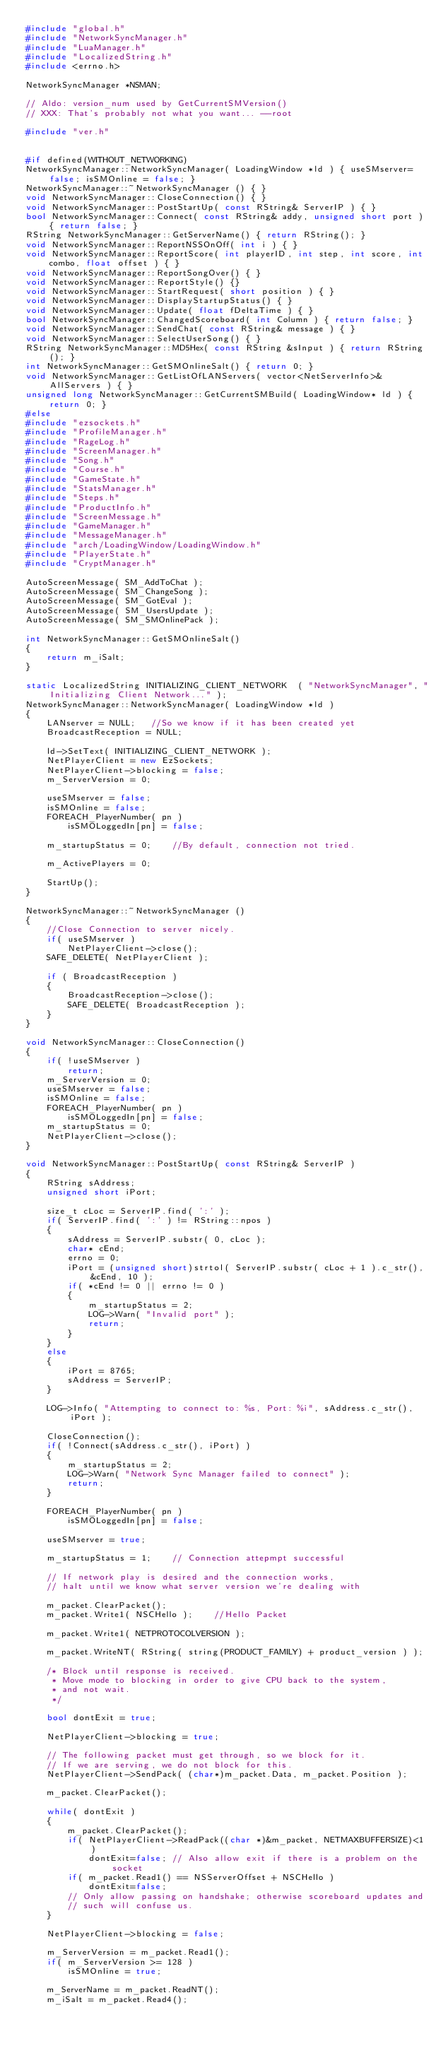Convert code to text. <code><loc_0><loc_0><loc_500><loc_500><_C++_>#include "global.h"
#include "NetworkSyncManager.h"
#include "LuaManager.h"
#include "LocalizedString.h"
#include <errno.h>

NetworkSyncManager *NSMAN;

// Aldo: version_num used by GetCurrentSMVersion()
// XXX: That's probably not what you want... --root

#include "ver.h"


#if defined(WITHOUT_NETWORKING)
NetworkSyncManager::NetworkSyncManager( LoadingWindow *ld ) { useSMserver=false; isSMOnline = false; }
NetworkSyncManager::~NetworkSyncManager () { }
void NetworkSyncManager::CloseConnection() { }
void NetworkSyncManager::PostStartUp( const RString& ServerIP ) { }
bool NetworkSyncManager::Connect( const RString& addy, unsigned short port ) { return false; }
RString NetworkSyncManager::GetServerName() { return RString(); }
void NetworkSyncManager::ReportNSSOnOff( int i ) { }
void NetworkSyncManager::ReportScore( int playerID, int step, int score, int combo, float offset ) { }
void NetworkSyncManager::ReportSongOver() { }
void NetworkSyncManager::ReportStyle() {}
void NetworkSyncManager::StartRequest( short position ) { }
void NetworkSyncManager::DisplayStartupStatus() { }
void NetworkSyncManager::Update( float fDeltaTime ) { }
bool NetworkSyncManager::ChangedScoreboard( int Column ) { return false; }
void NetworkSyncManager::SendChat( const RString& message ) { }
void NetworkSyncManager::SelectUserSong() { }
RString NetworkSyncManager::MD5Hex( const RString &sInput ) { return RString(); }
int NetworkSyncManager::GetSMOnlineSalt() { return 0; }
void NetworkSyncManager::GetListOfLANServers( vector<NetServerInfo>& AllServers ) { }
unsigned long NetworkSyncManager::GetCurrentSMBuild( LoadingWindow* ld ) { return 0; }
#else
#include "ezsockets.h"
#include "ProfileManager.h"
#include "RageLog.h"
#include "ScreenManager.h"
#include "Song.h"
#include "Course.h"
#include "GameState.h"
#include "StatsManager.h"
#include "Steps.h"
#include "ProductInfo.h"
#include "ScreenMessage.h"
#include "GameManager.h"
#include "MessageManager.h"
#include "arch/LoadingWindow/LoadingWindow.h"
#include "PlayerState.h"
#include "CryptManager.h"

AutoScreenMessage( SM_AddToChat );
AutoScreenMessage( SM_ChangeSong );
AutoScreenMessage( SM_GotEval );
AutoScreenMessage( SM_UsersUpdate );
AutoScreenMessage( SM_SMOnlinePack );

int NetworkSyncManager::GetSMOnlineSalt()
{
	return m_iSalt;
}

static LocalizedString INITIALIZING_CLIENT_NETWORK	( "NetworkSyncManager", "Initializing Client Network..." );
NetworkSyncManager::NetworkSyncManager( LoadingWindow *ld )
{
	LANserver = NULL;	//So we know if it has been created yet
	BroadcastReception = NULL;

	ld->SetText( INITIALIZING_CLIENT_NETWORK );
	NetPlayerClient = new EzSockets;
	NetPlayerClient->blocking = false;
	m_ServerVersion = 0;
   
	useSMserver = false;
	isSMOnline = false;
	FOREACH_PlayerNumber( pn )
		isSMOLoggedIn[pn] = false;

	m_startupStatus = 0;	//By default, connection not tried.

	m_ActivePlayers = 0;

	StartUp();
}

NetworkSyncManager::~NetworkSyncManager ()
{
	//Close Connection to server nicely.
	if( useSMserver )
		NetPlayerClient->close();
	SAFE_DELETE( NetPlayerClient );

	if ( BroadcastReception ) 
	{
		BroadcastReception->close();
		SAFE_DELETE( BroadcastReception );
	}
}

void NetworkSyncManager::CloseConnection()
{
	if( !useSMserver )
		return;
	m_ServerVersion = 0;
   	useSMserver = false;
	isSMOnline = false;
	FOREACH_PlayerNumber( pn )
		isSMOLoggedIn[pn] = false;
	m_startupStatus = 0;
	NetPlayerClient->close();
}

void NetworkSyncManager::PostStartUp( const RString& ServerIP )
{
	RString sAddress;
	unsigned short iPort;

	size_t cLoc = ServerIP.find( ':' );
	if( ServerIP.find( ':' ) != RString::npos )
	{
		sAddress = ServerIP.substr( 0, cLoc );
		char* cEnd;
		errno = 0;
		iPort = (unsigned short)strtol( ServerIP.substr( cLoc + 1 ).c_str(), &cEnd, 10 );
		if( *cEnd != 0 || errno != 0 )
		{
			m_startupStatus = 2;
			LOG->Warn( "Invalid port" );
			return;
		}
	}
	else
	{
		iPort = 8765;
		sAddress = ServerIP;
	}

	LOG->Info( "Attempting to connect to: %s, Port: %i", sAddress.c_str(), iPort );

	CloseConnection();
	if( !Connect(sAddress.c_str(), iPort) )
	{
		m_startupStatus = 2;
		LOG->Warn( "Network Sync Manager failed to connect" );
		return;
	}

	FOREACH_PlayerNumber( pn )
		isSMOLoggedIn[pn] = false;

	useSMserver = true;

	m_startupStatus = 1;	// Connection attepmpt successful

	// If network play is desired and the connection works,
	// halt until we know what server version we're dealing with

	m_packet.ClearPacket();
	m_packet.Write1( NSCHello );	//Hello Packet

	m_packet.Write1( NETPROTOCOLVERSION );

	m_packet.WriteNT( RString( string(PRODUCT_FAMILY) + product_version ) );

	/* Block until response is received.
	 * Move mode to blocking in order to give CPU back to the system,
	 * and not wait.
	 */

	bool dontExit = true;

	NetPlayerClient->blocking = true;

	// The following packet must get through, so we block for it.
	// If we are serving, we do not block for this.
	NetPlayerClient->SendPack( (char*)m_packet.Data, m_packet.Position );

	m_packet.ClearPacket();

	while( dontExit )
	{
		m_packet.ClearPacket();
		if( NetPlayerClient->ReadPack((char *)&m_packet, NETMAXBUFFERSIZE)<1 )
			dontExit=false; // Also allow exit if there is a problem on the socket
		if( m_packet.Read1() == NSServerOffset + NSCHello )
			dontExit=false;
		// Only allow passing on handshake; otherwise scoreboard updates and
		// such will confuse us.
	}

	NetPlayerClient->blocking = false;

	m_ServerVersion = m_packet.Read1();
	if( m_ServerVersion >= 128 )
		isSMOnline = true;

	m_ServerName = m_packet.ReadNT();
	m_iSalt = m_packet.Read4();</code> 